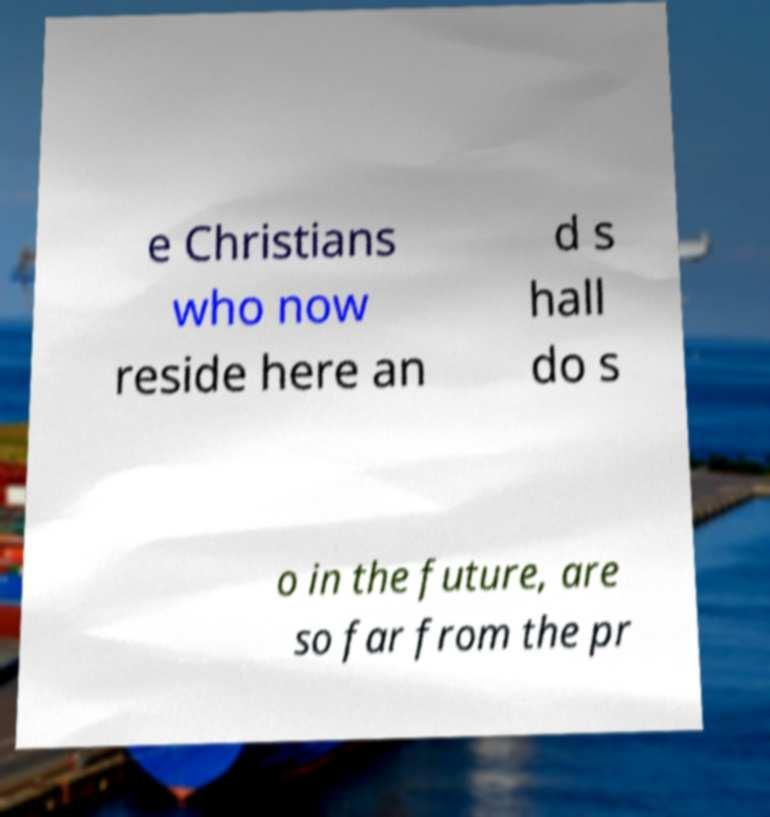Please identify and transcribe the text found in this image. e Christians who now reside here an d s hall do s o in the future, are so far from the pr 